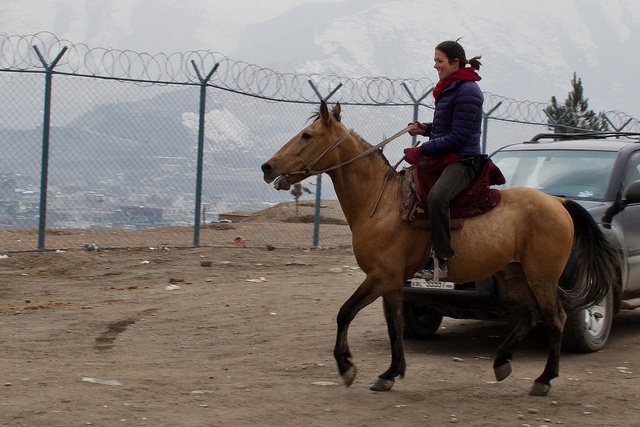Describe the objects in this image and their specific colors. I can see horse in lightgray, black, maroon, and gray tones, car in lightgray, gray, darkgray, and black tones, people in lightgray, black, maroon, gray, and navy tones, car in lightgray, black, gray, and darkgray tones, and car in lightgray, gray, darkgray, and darkblue tones in this image. 